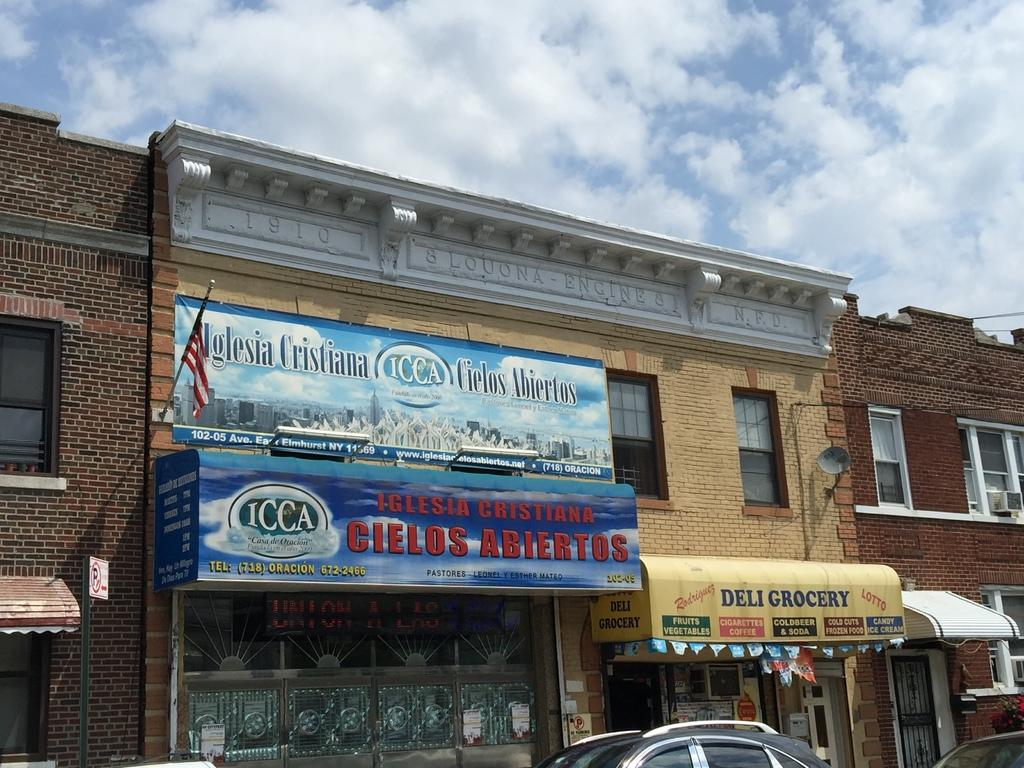What type of structure is visible in the image? There is a building in the image. What is located at the bottom of the image? There is a car at the bottom of the image. What can be seen on the wall of the building? There is a flag on the wall. What is visible in the sky in the image? There are clouds in the sky. What type of trousers are hanging from the flagpole in the image? There are no trousers present in the image, and the flag is not hanging from a flagpole. Can you describe the attempt made by the clouds to cover the building in the image? The clouds are not attempting to cover the building; they are simply visible in the sky. 